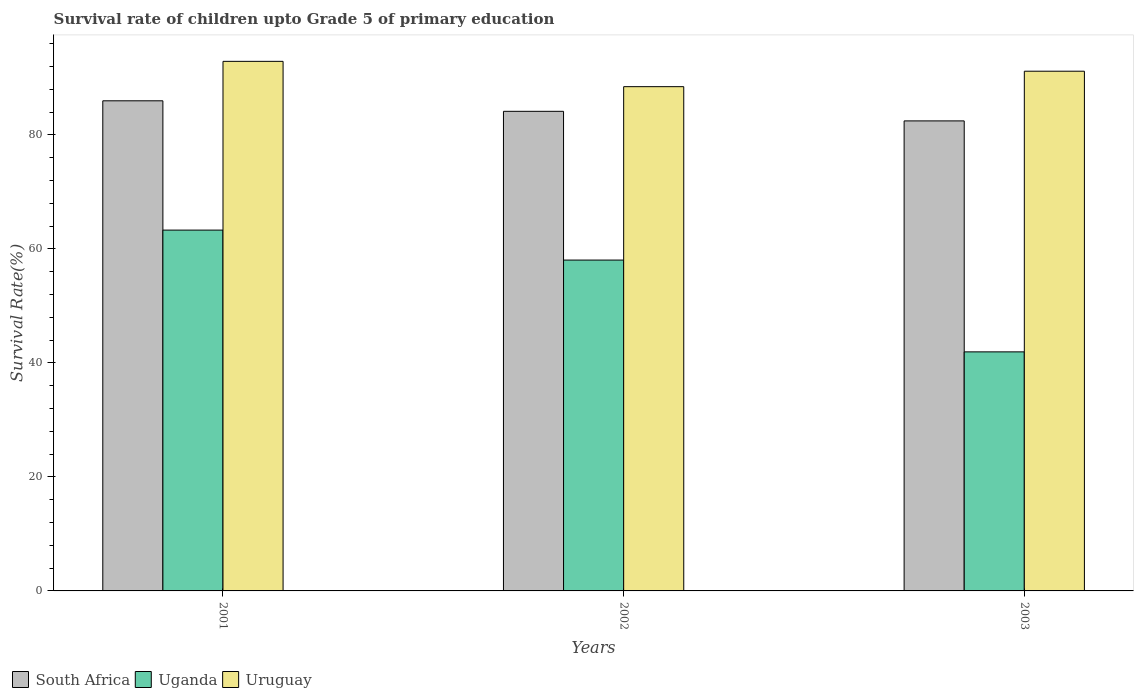How many bars are there on the 2nd tick from the left?
Give a very brief answer. 3. What is the survival rate of children in South Africa in 2003?
Your response must be concise. 82.45. Across all years, what is the maximum survival rate of children in Uruguay?
Give a very brief answer. 92.89. Across all years, what is the minimum survival rate of children in South Africa?
Keep it short and to the point. 82.45. In which year was the survival rate of children in South Africa maximum?
Provide a short and direct response. 2001. What is the total survival rate of children in South Africa in the graph?
Provide a short and direct response. 252.55. What is the difference between the survival rate of children in Uruguay in 2001 and that in 2003?
Offer a terse response. 1.73. What is the difference between the survival rate of children in Uruguay in 2001 and the survival rate of children in South Africa in 2002?
Your response must be concise. 8.77. What is the average survival rate of children in Uganda per year?
Ensure brevity in your answer.  54.42. In the year 2002, what is the difference between the survival rate of children in South Africa and survival rate of children in Uruguay?
Ensure brevity in your answer.  -4.33. What is the ratio of the survival rate of children in South Africa in 2001 to that in 2003?
Make the answer very short. 1.04. Is the survival rate of children in Uruguay in 2001 less than that in 2003?
Make the answer very short. No. What is the difference between the highest and the second highest survival rate of children in South Africa?
Your response must be concise. 1.85. What is the difference between the highest and the lowest survival rate of children in Uruguay?
Offer a terse response. 4.44. What does the 1st bar from the left in 2003 represents?
Your answer should be compact. South Africa. What does the 3rd bar from the right in 2002 represents?
Give a very brief answer. South Africa. Is it the case that in every year, the sum of the survival rate of children in South Africa and survival rate of children in Uruguay is greater than the survival rate of children in Uganda?
Make the answer very short. Yes. Are the values on the major ticks of Y-axis written in scientific E-notation?
Keep it short and to the point. No. What is the title of the graph?
Give a very brief answer. Survival rate of children upto Grade 5 of primary education. What is the label or title of the X-axis?
Provide a short and direct response. Years. What is the label or title of the Y-axis?
Keep it short and to the point. Survival Rate(%). What is the Survival Rate(%) in South Africa in 2001?
Your answer should be very brief. 85.97. What is the Survival Rate(%) of Uganda in 2001?
Make the answer very short. 63.29. What is the Survival Rate(%) in Uruguay in 2001?
Your answer should be very brief. 92.89. What is the Survival Rate(%) in South Africa in 2002?
Keep it short and to the point. 84.13. What is the Survival Rate(%) of Uganda in 2002?
Offer a terse response. 58.04. What is the Survival Rate(%) of Uruguay in 2002?
Make the answer very short. 88.45. What is the Survival Rate(%) of South Africa in 2003?
Offer a very short reply. 82.45. What is the Survival Rate(%) in Uganda in 2003?
Your response must be concise. 41.93. What is the Survival Rate(%) in Uruguay in 2003?
Ensure brevity in your answer.  91.17. Across all years, what is the maximum Survival Rate(%) of South Africa?
Ensure brevity in your answer.  85.97. Across all years, what is the maximum Survival Rate(%) in Uganda?
Offer a very short reply. 63.29. Across all years, what is the maximum Survival Rate(%) in Uruguay?
Give a very brief answer. 92.89. Across all years, what is the minimum Survival Rate(%) in South Africa?
Keep it short and to the point. 82.45. Across all years, what is the minimum Survival Rate(%) in Uganda?
Provide a succinct answer. 41.93. Across all years, what is the minimum Survival Rate(%) of Uruguay?
Your response must be concise. 88.45. What is the total Survival Rate(%) of South Africa in the graph?
Give a very brief answer. 252.55. What is the total Survival Rate(%) in Uganda in the graph?
Give a very brief answer. 163.26. What is the total Survival Rate(%) in Uruguay in the graph?
Offer a terse response. 272.51. What is the difference between the Survival Rate(%) in South Africa in 2001 and that in 2002?
Your answer should be compact. 1.85. What is the difference between the Survival Rate(%) of Uganda in 2001 and that in 2002?
Provide a short and direct response. 5.26. What is the difference between the Survival Rate(%) of Uruguay in 2001 and that in 2002?
Provide a short and direct response. 4.44. What is the difference between the Survival Rate(%) of South Africa in 2001 and that in 2003?
Provide a short and direct response. 3.52. What is the difference between the Survival Rate(%) in Uganda in 2001 and that in 2003?
Keep it short and to the point. 21.36. What is the difference between the Survival Rate(%) in Uruguay in 2001 and that in 2003?
Keep it short and to the point. 1.73. What is the difference between the Survival Rate(%) of South Africa in 2002 and that in 2003?
Provide a short and direct response. 1.68. What is the difference between the Survival Rate(%) in Uganda in 2002 and that in 2003?
Your answer should be very brief. 16.1. What is the difference between the Survival Rate(%) of Uruguay in 2002 and that in 2003?
Keep it short and to the point. -2.71. What is the difference between the Survival Rate(%) of South Africa in 2001 and the Survival Rate(%) of Uganda in 2002?
Offer a terse response. 27.94. What is the difference between the Survival Rate(%) in South Africa in 2001 and the Survival Rate(%) in Uruguay in 2002?
Ensure brevity in your answer.  -2.48. What is the difference between the Survival Rate(%) of Uganda in 2001 and the Survival Rate(%) of Uruguay in 2002?
Your answer should be very brief. -25.16. What is the difference between the Survival Rate(%) of South Africa in 2001 and the Survival Rate(%) of Uganda in 2003?
Offer a terse response. 44.04. What is the difference between the Survival Rate(%) of South Africa in 2001 and the Survival Rate(%) of Uruguay in 2003?
Provide a short and direct response. -5.19. What is the difference between the Survival Rate(%) of Uganda in 2001 and the Survival Rate(%) of Uruguay in 2003?
Your answer should be very brief. -27.87. What is the difference between the Survival Rate(%) in South Africa in 2002 and the Survival Rate(%) in Uganda in 2003?
Offer a terse response. 42.2. What is the difference between the Survival Rate(%) of South Africa in 2002 and the Survival Rate(%) of Uruguay in 2003?
Ensure brevity in your answer.  -7.04. What is the difference between the Survival Rate(%) of Uganda in 2002 and the Survival Rate(%) of Uruguay in 2003?
Make the answer very short. -33.13. What is the average Survival Rate(%) in South Africa per year?
Your answer should be very brief. 84.18. What is the average Survival Rate(%) of Uganda per year?
Offer a very short reply. 54.42. What is the average Survival Rate(%) in Uruguay per year?
Provide a short and direct response. 90.84. In the year 2001, what is the difference between the Survival Rate(%) in South Africa and Survival Rate(%) in Uganda?
Your answer should be compact. 22.68. In the year 2001, what is the difference between the Survival Rate(%) in South Africa and Survival Rate(%) in Uruguay?
Make the answer very short. -6.92. In the year 2001, what is the difference between the Survival Rate(%) in Uganda and Survival Rate(%) in Uruguay?
Your answer should be compact. -29.6. In the year 2002, what is the difference between the Survival Rate(%) of South Africa and Survival Rate(%) of Uganda?
Keep it short and to the point. 26.09. In the year 2002, what is the difference between the Survival Rate(%) in South Africa and Survival Rate(%) in Uruguay?
Your response must be concise. -4.33. In the year 2002, what is the difference between the Survival Rate(%) in Uganda and Survival Rate(%) in Uruguay?
Offer a very short reply. -30.42. In the year 2003, what is the difference between the Survival Rate(%) in South Africa and Survival Rate(%) in Uganda?
Your response must be concise. 40.52. In the year 2003, what is the difference between the Survival Rate(%) in South Africa and Survival Rate(%) in Uruguay?
Offer a terse response. -8.72. In the year 2003, what is the difference between the Survival Rate(%) of Uganda and Survival Rate(%) of Uruguay?
Your answer should be compact. -49.23. What is the ratio of the Survival Rate(%) in South Africa in 2001 to that in 2002?
Offer a terse response. 1.02. What is the ratio of the Survival Rate(%) in Uganda in 2001 to that in 2002?
Keep it short and to the point. 1.09. What is the ratio of the Survival Rate(%) of Uruguay in 2001 to that in 2002?
Provide a short and direct response. 1.05. What is the ratio of the Survival Rate(%) of South Africa in 2001 to that in 2003?
Your response must be concise. 1.04. What is the ratio of the Survival Rate(%) in Uganda in 2001 to that in 2003?
Ensure brevity in your answer.  1.51. What is the ratio of the Survival Rate(%) of South Africa in 2002 to that in 2003?
Keep it short and to the point. 1.02. What is the ratio of the Survival Rate(%) of Uganda in 2002 to that in 2003?
Keep it short and to the point. 1.38. What is the ratio of the Survival Rate(%) of Uruguay in 2002 to that in 2003?
Offer a terse response. 0.97. What is the difference between the highest and the second highest Survival Rate(%) in South Africa?
Ensure brevity in your answer.  1.85. What is the difference between the highest and the second highest Survival Rate(%) in Uganda?
Provide a succinct answer. 5.26. What is the difference between the highest and the second highest Survival Rate(%) of Uruguay?
Give a very brief answer. 1.73. What is the difference between the highest and the lowest Survival Rate(%) of South Africa?
Offer a very short reply. 3.52. What is the difference between the highest and the lowest Survival Rate(%) in Uganda?
Ensure brevity in your answer.  21.36. What is the difference between the highest and the lowest Survival Rate(%) in Uruguay?
Your answer should be very brief. 4.44. 